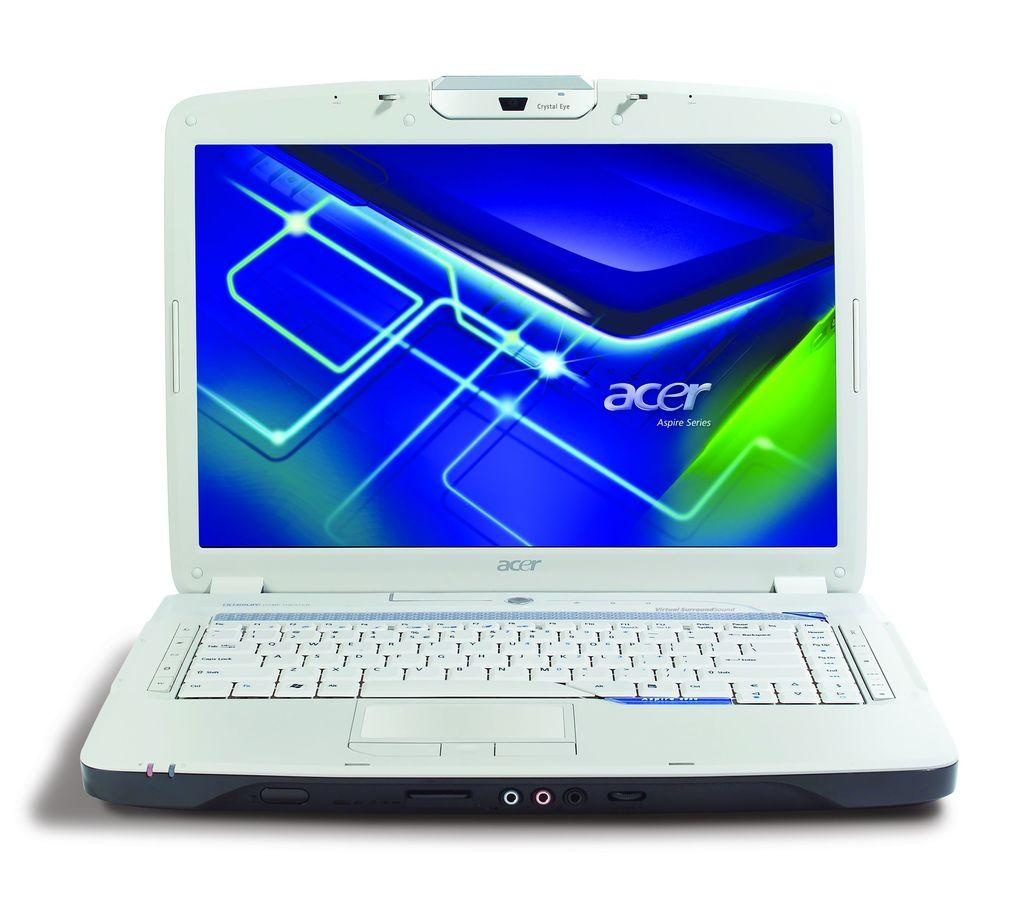<image>
Summarize the visual content of the image. Old silver laptop with a screen that says Acer on it. 